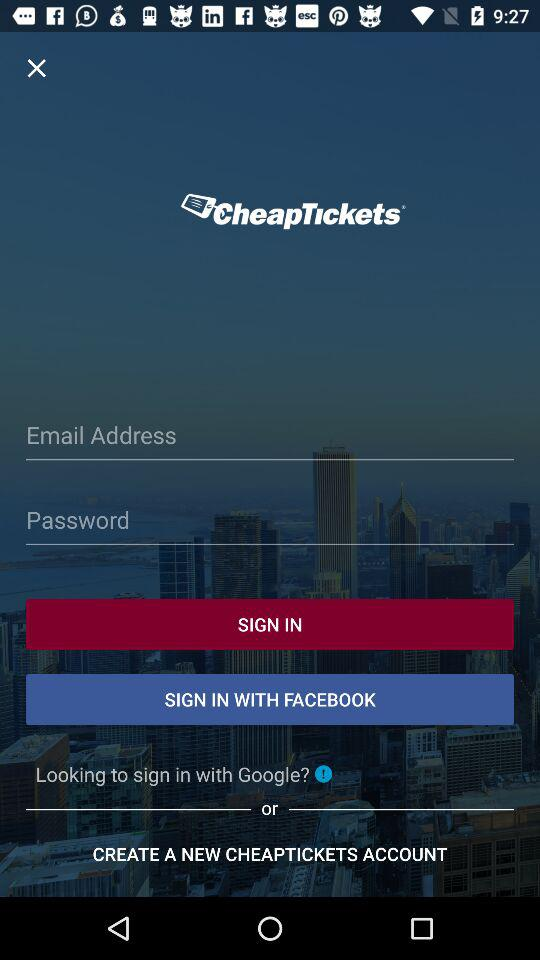What are the requirements to sign in? The requirements to sign in are an email address and a password. 